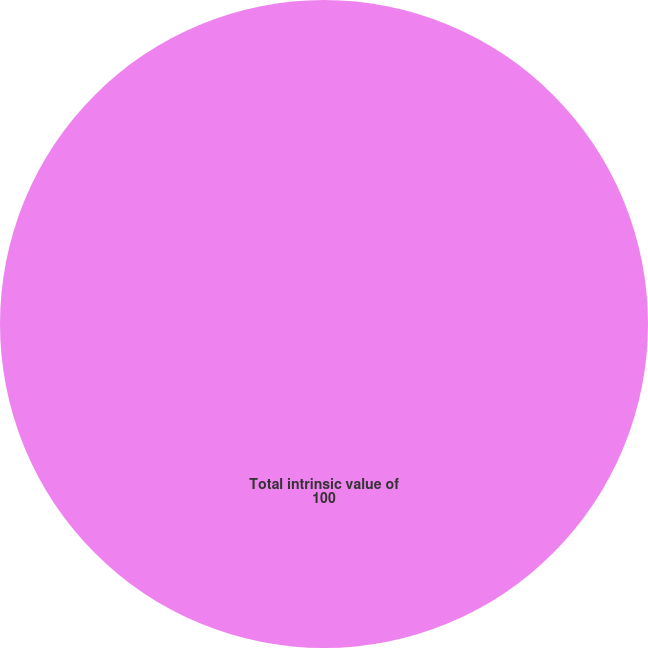<chart> <loc_0><loc_0><loc_500><loc_500><pie_chart><fcel>Total intrinsic value of<nl><fcel>100.0%<nl></chart> 